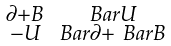<formula> <loc_0><loc_0><loc_500><loc_500>\begin{smallmatrix} \partial + B & \ B a r { U } \\ - U & \ B a r { \partial } + \ B a r { B } \end{smallmatrix}</formula> 